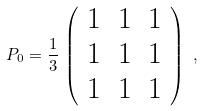<formula> <loc_0><loc_0><loc_500><loc_500>P _ { 0 } = \frac { 1 } { 3 } \, \left ( \begin{array} { c c c } 1 & 1 & 1 \\ 1 & 1 & 1 \\ 1 & 1 & 1 \end{array} \right ) \ ,</formula> 